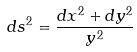Convert formula to latex. <formula><loc_0><loc_0><loc_500><loc_500>d s ^ { 2 } = \frac { d x ^ { 2 } + d y ^ { 2 } } { y ^ { 2 } }</formula> 